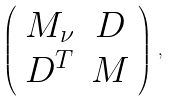Convert formula to latex. <formula><loc_0><loc_0><loc_500><loc_500>\left ( \begin{array} { c c } M _ { \nu } & D \\ D ^ { T } & M \end{array} \right ) \, ,</formula> 